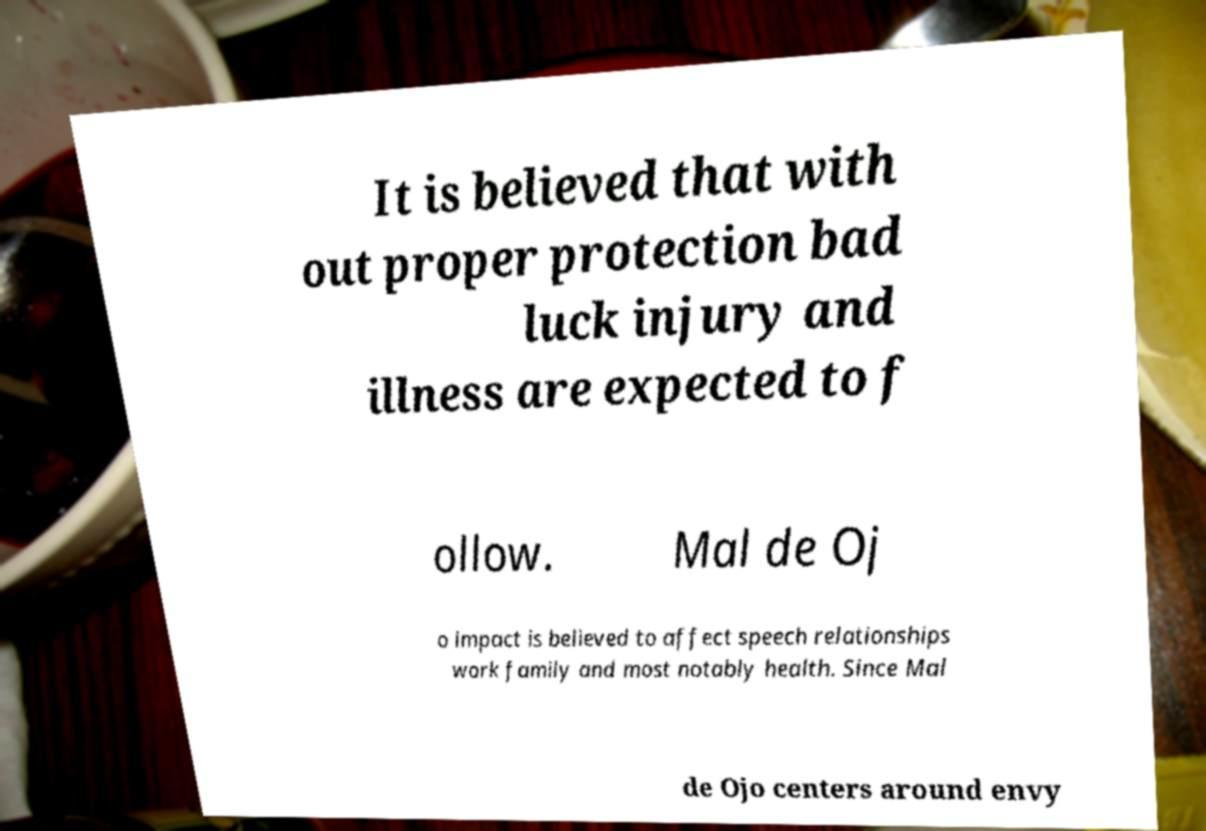Can you read and provide the text displayed in the image?This photo seems to have some interesting text. Can you extract and type it out for me? It is believed that with out proper protection bad luck injury and illness are expected to f ollow. Mal de Oj o impact is believed to affect speech relationships work family and most notably health. Since Mal de Ojo centers around envy 